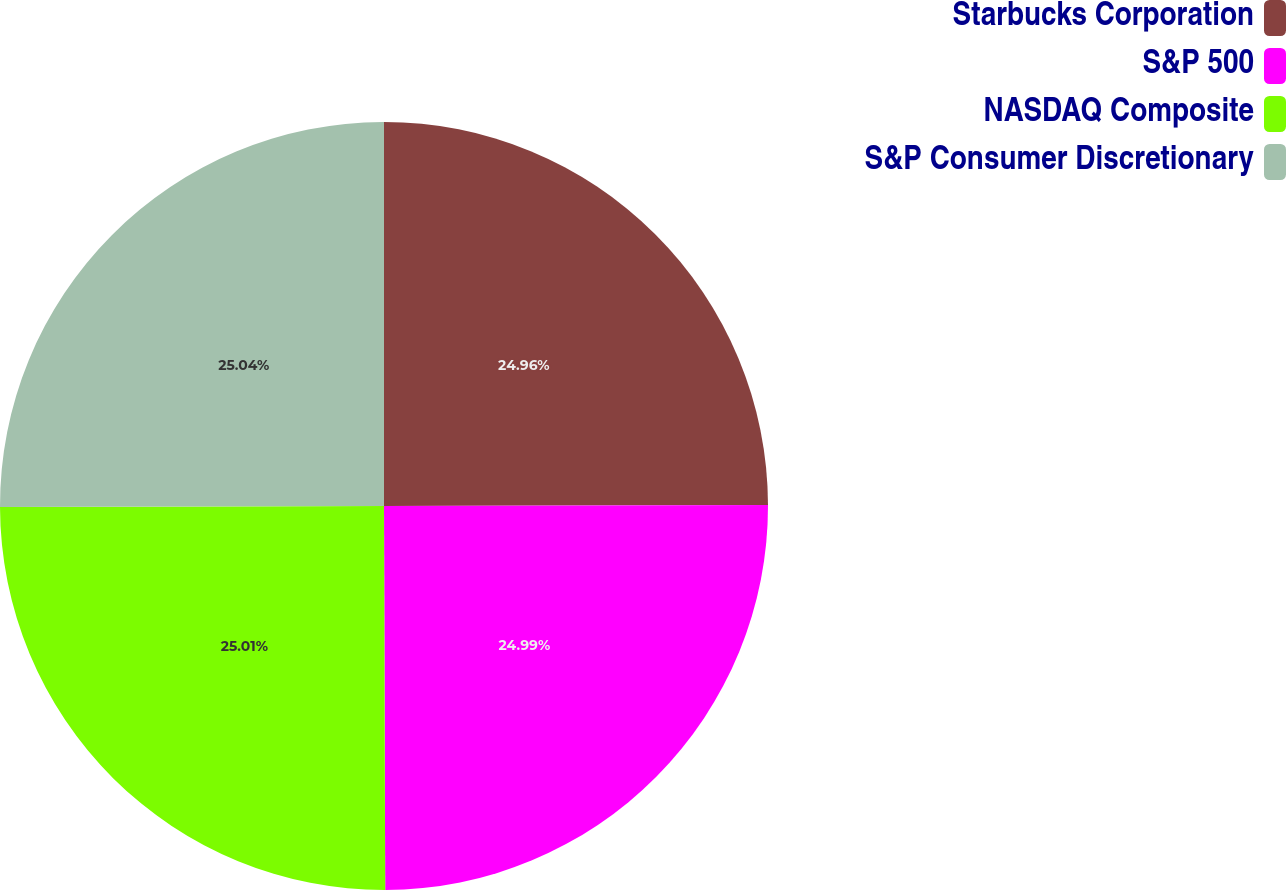Convert chart to OTSL. <chart><loc_0><loc_0><loc_500><loc_500><pie_chart><fcel>Starbucks Corporation<fcel>S&P 500<fcel>NASDAQ Composite<fcel>S&P Consumer Discretionary<nl><fcel>24.96%<fcel>24.99%<fcel>25.01%<fcel>25.04%<nl></chart> 